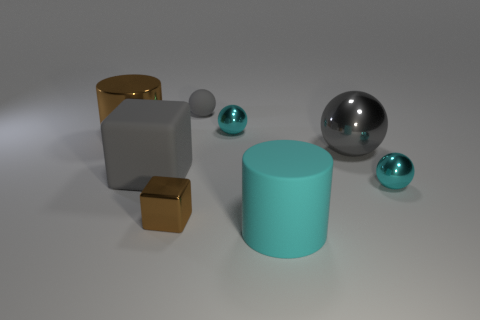Do the tiny brown object and the big gray rubber thing have the same shape?
Provide a succinct answer. Yes. What number of other things are there of the same material as the large gray cube
Give a very brief answer. 2. There is a gray matte object behind the big matte object behind the tiny block; what is its shape?
Your answer should be very brief. Sphere. What number of things are either big gray cubes or tiny metal objects that are behind the tiny shiny cube?
Your answer should be very brief. 3. What number of other things are there of the same color as the small block?
Offer a terse response. 1. What number of gray things are rubber spheres or tiny metal things?
Your answer should be very brief. 1. Is there a block behind the cyan sphere that is behind the big rubber object behind the tiny metal block?
Give a very brief answer. No. Is the tiny rubber thing the same color as the big ball?
Your answer should be very brief. Yes. The big metallic ball to the right of the small cyan shiny sphere that is to the left of the large cyan matte cylinder is what color?
Make the answer very short. Gray. How many big things are either cyan rubber things or brown shiny cylinders?
Your answer should be compact. 2. 